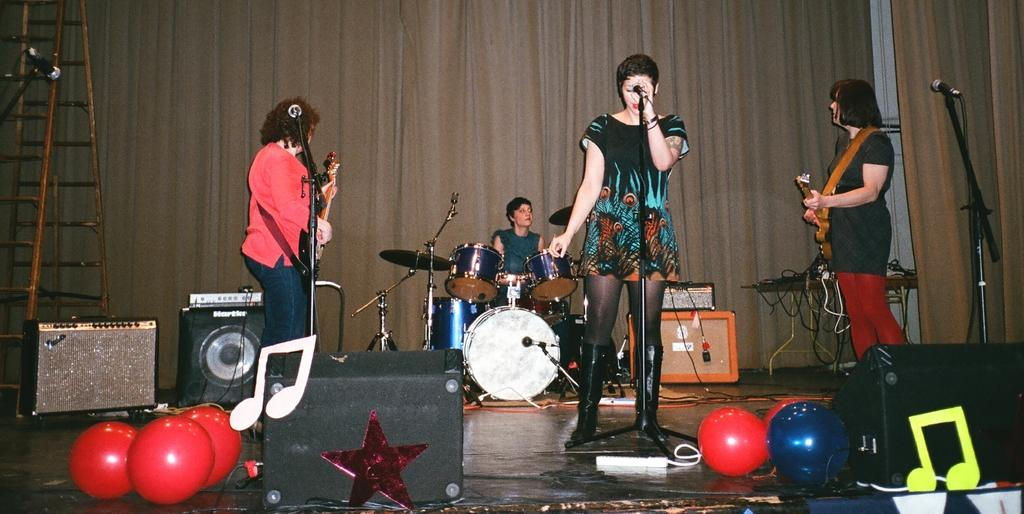What type of people are in the image? There is a group of people in the image, and they are musicians. What items are necessary for the musicians to perform? Musical instruments and microphones are visible in the image. What equipment is used to amplify the sound in the image? Sound systems are present in the image. What additional decorative items can be seen in the image? Balloons are in the image. What type of scissors are being used to cut the air in the image? There are no scissors present in the image, and the musicians are not cutting the air with any tools. 